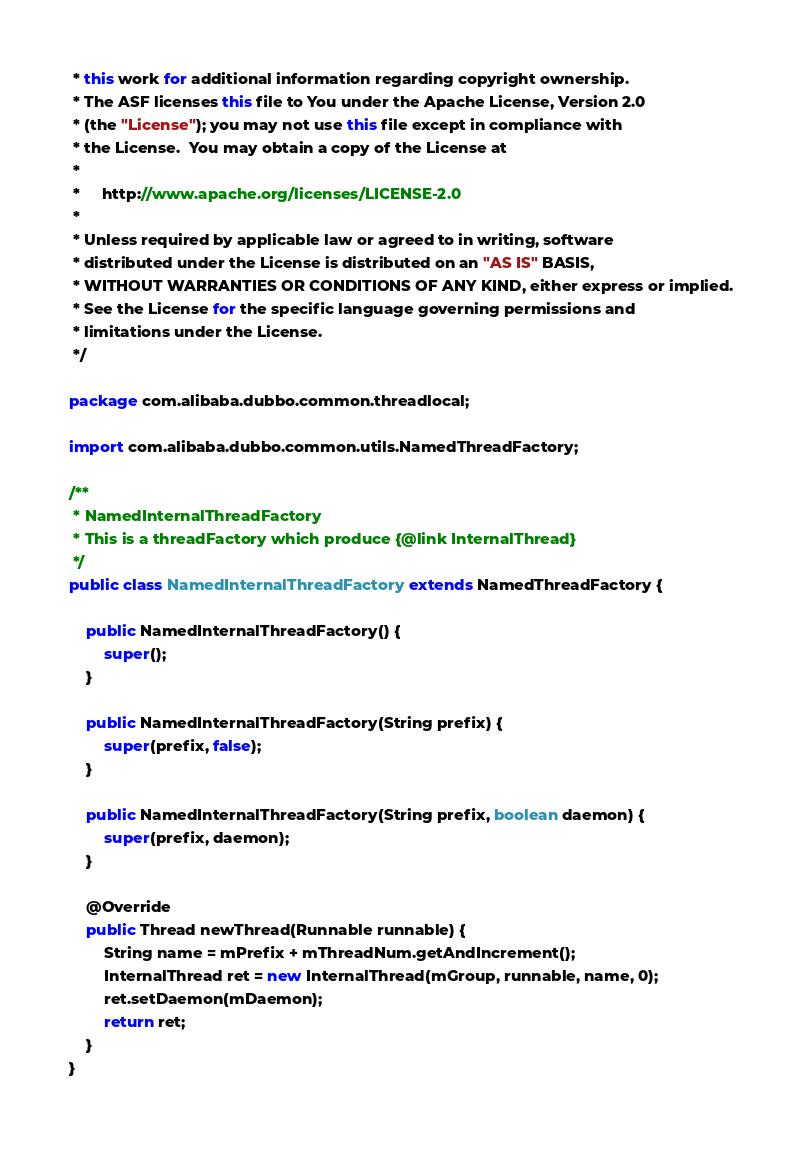Convert code to text. <code><loc_0><loc_0><loc_500><loc_500><_Java_> * this work for additional information regarding copyright ownership.
 * The ASF licenses this file to You under the Apache License, Version 2.0
 * (the "License"); you may not use this file except in compliance with
 * the License.  You may obtain a copy of the License at
 *
 *     http://www.apache.org/licenses/LICENSE-2.0
 *
 * Unless required by applicable law or agreed to in writing, software
 * distributed under the License is distributed on an "AS IS" BASIS,
 * WITHOUT WARRANTIES OR CONDITIONS OF ANY KIND, either express or implied.
 * See the License for the specific language governing permissions and
 * limitations under the License.
 */

package com.alibaba.dubbo.common.threadlocal;

import com.alibaba.dubbo.common.utils.NamedThreadFactory;

/**
 * NamedInternalThreadFactory
 * This is a threadFactory which produce {@link InternalThread}
 */
public class NamedInternalThreadFactory extends NamedThreadFactory {

    public NamedInternalThreadFactory() {
        super();
    }

    public NamedInternalThreadFactory(String prefix) {
        super(prefix, false);
    }

    public NamedInternalThreadFactory(String prefix, boolean daemon) {
        super(prefix, daemon);
    }

    @Override
    public Thread newThread(Runnable runnable) {
        String name = mPrefix + mThreadNum.getAndIncrement();
        InternalThread ret = new InternalThread(mGroup, runnable, name, 0);
        ret.setDaemon(mDaemon);
        return ret;
    }
}
</code> 